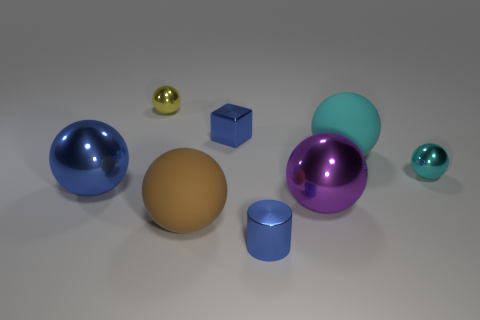How big is the metal sphere that is both behind the large blue ball and right of the yellow shiny sphere?
Offer a terse response. Small. Are there an equal number of yellow things that are in front of the cyan metal thing and red shiny spheres?
Offer a terse response. Yes. Is the blue shiny cylinder the same size as the blue metal block?
Keep it short and to the point. Yes. There is a shiny sphere that is in front of the tiny cyan thing and to the left of the big purple ball; what is its color?
Offer a very short reply. Blue. What material is the cyan thing that is left of the tiny ball in front of the blue cube made of?
Your response must be concise. Rubber. What size is the blue object that is the same shape as the purple metallic object?
Offer a very short reply. Large. There is a big metal thing to the left of the shiny cube; is its color the same as the cylinder?
Offer a very short reply. Yes. Are there fewer blue cylinders than big shiny spheres?
Keep it short and to the point. Yes. How many other objects are the same color as the tiny metallic cube?
Your answer should be very brief. 2. Is the tiny ball on the left side of the blue metal block made of the same material as the large brown object?
Ensure brevity in your answer.  No. 